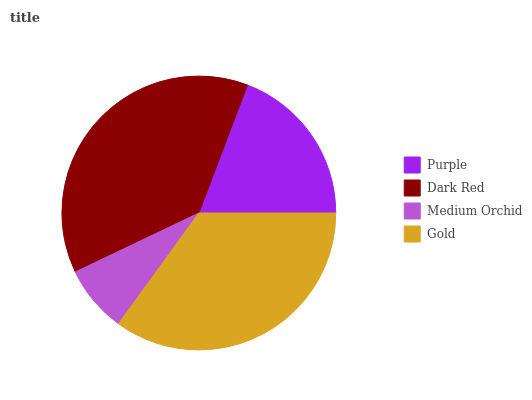Is Medium Orchid the minimum?
Answer yes or no. Yes. Is Dark Red the maximum?
Answer yes or no. Yes. Is Dark Red the minimum?
Answer yes or no. No. Is Medium Orchid the maximum?
Answer yes or no. No. Is Dark Red greater than Medium Orchid?
Answer yes or no. Yes. Is Medium Orchid less than Dark Red?
Answer yes or no. Yes. Is Medium Orchid greater than Dark Red?
Answer yes or no. No. Is Dark Red less than Medium Orchid?
Answer yes or no. No. Is Gold the high median?
Answer yes or no. Yes. Is Purple the low median?
Answer yes or no. Yes. Is Purple the high median?
Answer yes or no. No. Is Medium Orchid the low median?
Answer yes or no. No. 